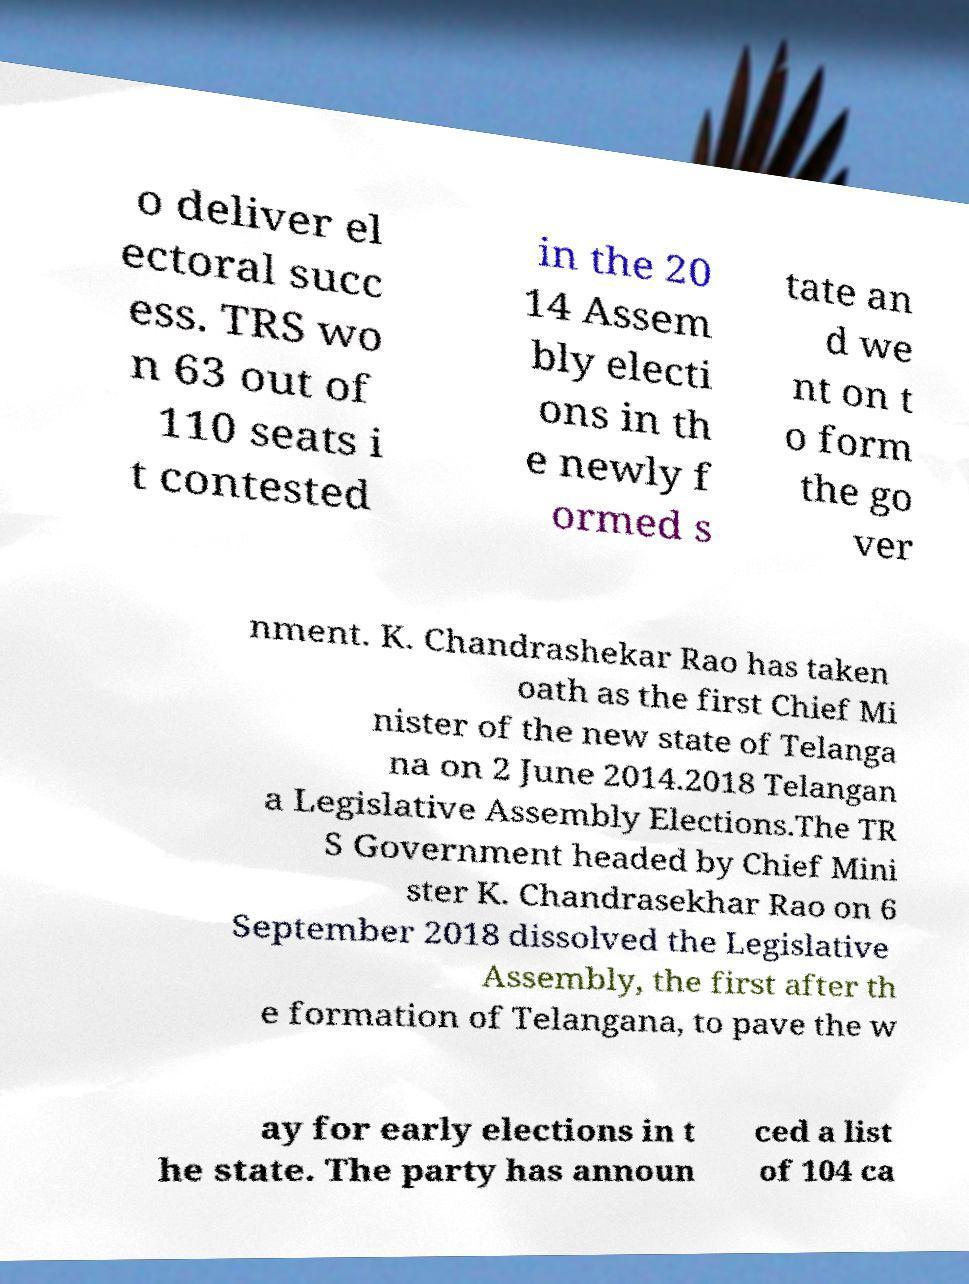Can you read and provide the text displayed in the image?This photo seems to have some interesting text. Can you extract and type it out for me? o deliver el ectoral succ ess. TRS wo n 63 out of 110 seats i t contested in the 20 14 Assem bly electi ons in th e newly f ormed s tate an d we nt on t o form the go ver nment. K. Chandrashekar Rao has taken oath as the first Chief Mi nister of the new state of Telanga na on 2 June 2014.2018 Telangan a Legislative Assembly Elections.The TR S Government headed by Chief Mini ster K. Chandrasekhar Rao on 6 September 2018 dissolved the Legislative Assembly, the first after th e formation of Telangana, to pave the w ay for early elections in t he state. The party has announ ced a list of 104 ca 